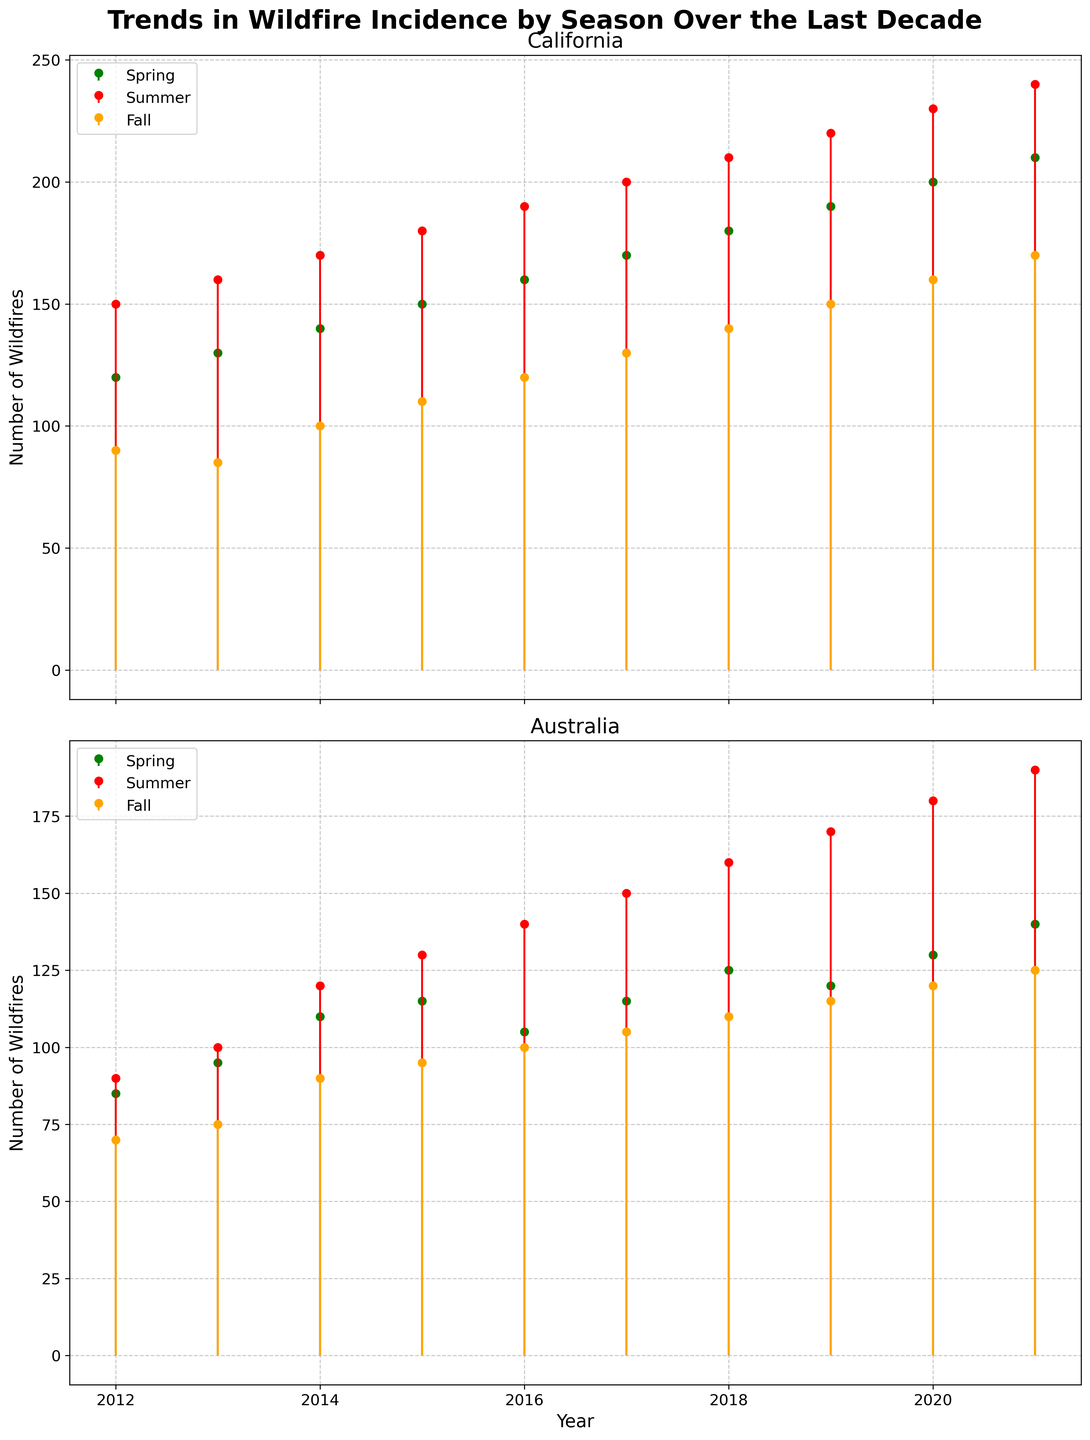What's the title of the figure? The title is located at the top of the figure, written in bold and larger font. It reads "Trends in Wildfire Incidence by Season Over the Last Decade".
Answer: Trends in Wildfire Incidence by Season Over the Last Decade How many separate plots are there in the figure? The figure consists of two separate plots, one for California at the top and one for Australia at the bottom, as indicated by their titles.
Answer: 2 Which season shows the highest number of wildfires on average in California? To determine this, visually inspect the stem lines for each season in California. Summer consistently has higher wildfire counts compared to Spring and Fall.
Answer: Summer Which year had the highest number of wildfires in Australia during the summer? Look at the stem plot lines for Australia's summer. 2021 shows the highest number of wildfires with a peak at 190.
Answer: 2021 What trend can be observed in the summer wildfire numbers in California over the last decade? Examine the stem lines for California's summer over the years. There is a clear upward trend, indicating that the number of wildfires has increased each year.
Answer: Increasing What is the difference in the number of wildfires between spring and fall in Australia for the year 2020? For Australia in 2020, locate the green stem for spring and the orange stem for fall. The counts are 130 for spring and 120 for fall. The difference is 130 - 120 = 10.
Answer: 10 How does the number of wildfires in California in summer 2015 compare to summer 2021? Identify the summer wildfire counts for California in 2015 and 2021 from the red stems. In 2015, it's 180 and in 2021, it's 240. 240 is greater than 180.
Answer: Higher What is the general pattern for the number of wildfires in Australia across the seasons from 2012 to 2021? Observe the stems for Australia over the years for each season. All seasons show an increasing trend, but summer has the most prominent and consistent increase.
Answer: Increasing trend, especially in summer On average, did summers in California have more wildfires compared to summers in Australia from 2012 to 2021? Compare the heights of the summer stem lines (red) for both California and Australia. California consistently shows higher wildfire counts compared to Australia.
Answer: Yes 